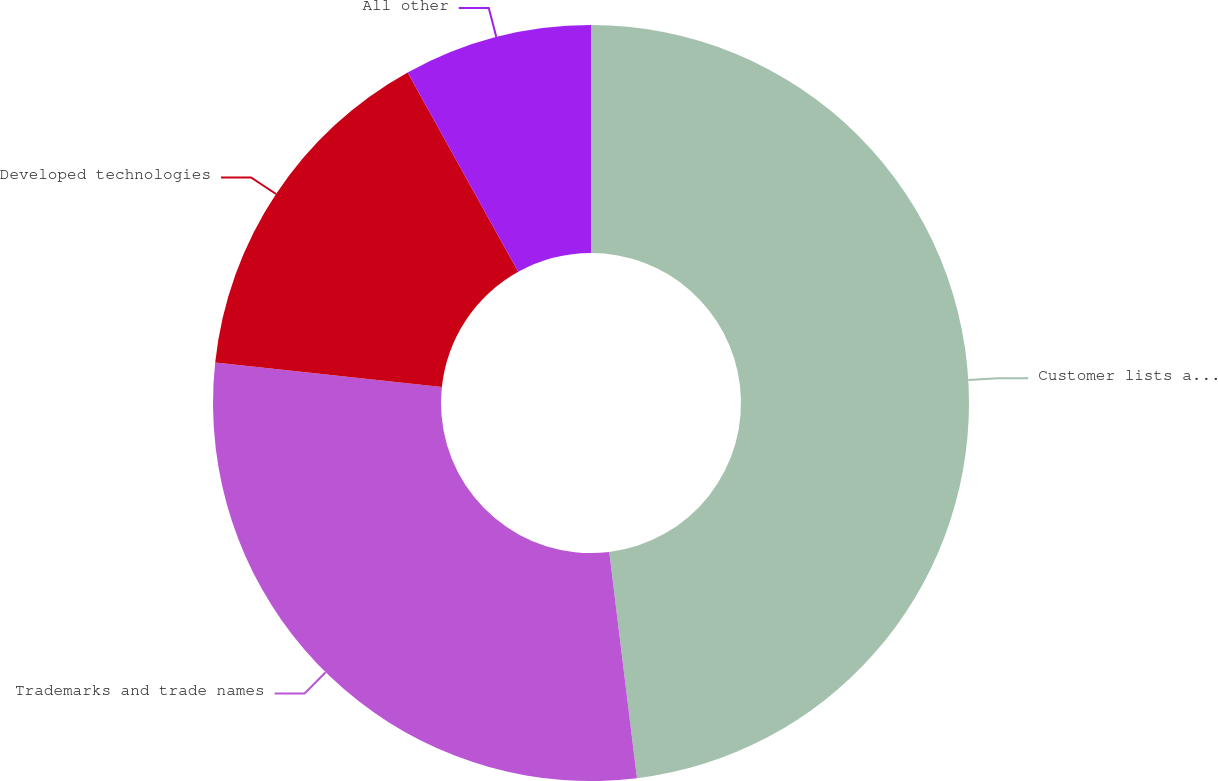Convert chart to OTSL. <chart><loc_0><loc_0><loc_500><loc_500><pie_chart><fcel>Customer lists and user base<fcel>Trademarks and trade names<fcel>Developed technologies<fcel>All other<nl><fcel>48.06%<fcel>28.65%<fcel>15.23%<fcel>8.06%<nl></chart> 